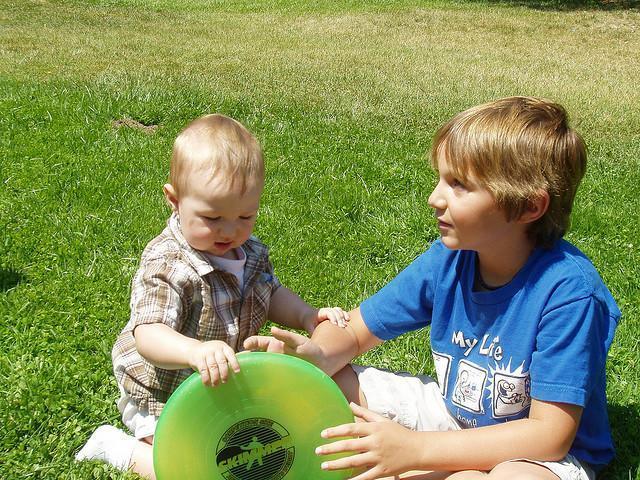How many people are in the picture?
Give a very brief answer. 2. How many live dogs are in the picture?
Give a very brief answer. 0. 